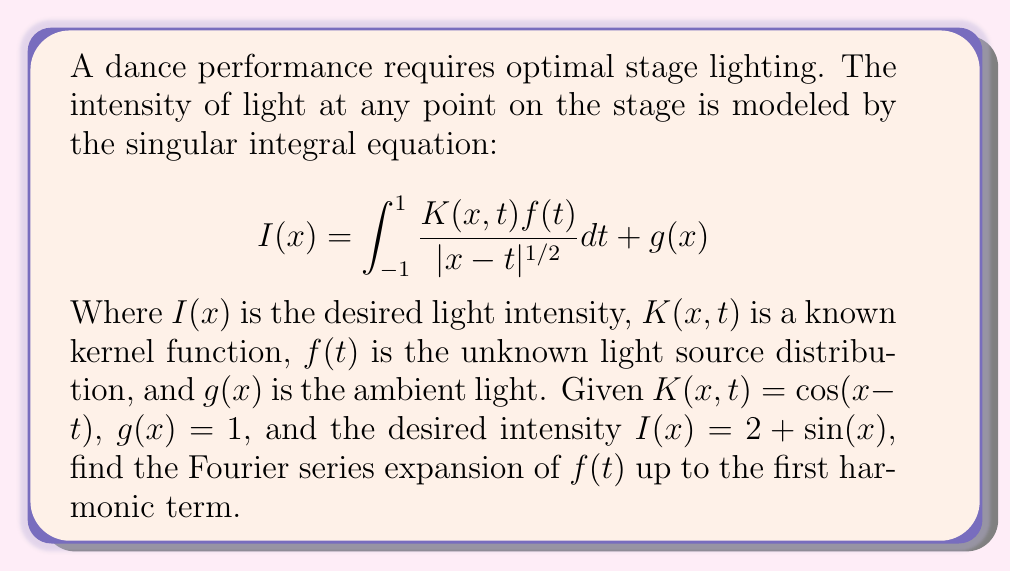Can you answer this question? To solve this problem, we'll follow these steps:

1) First, we need to recognize that this is a singular integral equation of the first kind with a weakly singular kernel. The solution can be approximated using a Fourier series expansion.

2) We assume $f(t)$ can be expressed as a Fourier series:

   $$f(t) = a_0 + a_1 \cos(t) + b_1 \sin(t) + \text{higher order terms}$$

3) Substitute this into the original equation:

   $$2 + \sin(x) = \int_{-1}^{1} \frac{\cos(x-t)(a_0 + a_1 \cos(t) + b_1 \sin(t))}{|x-t|^{1/2}} dt + 1$$

4) Using trigonometric identities, expand $\cos(x-t)$:

   $$2 + \sin(x) = \int_{-1}^{1} \frac{(\cos(x)\cos(t) + \sin(x)\sin(t))(a_0 + a_1 \cos(t) + b_1 \sin(t))}{|x-t|^{1/2}} dt + 1$$

5) Distribute and collect terms:

   $$2 + \sin(x) = a_0 \cos(x) \int_{-1}^{1} \frac{\cos(t)}{|x-t|^{1/2}} dt + a_0 \sin(x) \int_{-1}^{1} \frac{\sin(t)}{|x-t|^{1/2}} dt + ...$$

6) The integrals in this equation are known as Cauchy principal value integrals. Their values are:

   $$\int_{-1}^{1} \frac{\cos(t)}{|x-t|^{1/2}} dt = \pi \cos(x)$$
   $$\int_{-1}^{1} \frac{\sin(t)}{|x-t|^{1/2}} dt = \pi \sin(x)$$

7) After evaluating all integrals and collecting terms, we get:

   $$2 + \sin(x) = \pi a_0 \cos(x) + \pi a_0 \sin(x) + \frac{\pi}{2}a_1 + \frac{\pi}{2}b_1 \sin(x) + 1$$

8) Equating coefficients:

   Constant term: $2 = \frac{\pi}{2}a_1 + 1$, so $a_1 = \frac{2}{\pi}$
   $\sin(x)$ term: $1 = \pi a_0 + \frac{\pi}{2}b_1$, so $b_1 = \frac{2}{\pi} - 2a_0$
   $\cos(x)$ term: $0 = \pi a_0$, so $a_0 = 0$

9) Therefore, $b_1 = \frac{2}{\pi}$

Thus, the Fourier series expansion of $f(t)$ up to the first harmonic term is:

$$f(t) = \frac{2}{\pi}\cos(t) + \frac{2}{\pi}\sin(t)$$
Answer: $$f(t) = \frac{2}{\pi}\cos(t) + \frac{2}{\pi}\sin(t)$$ 